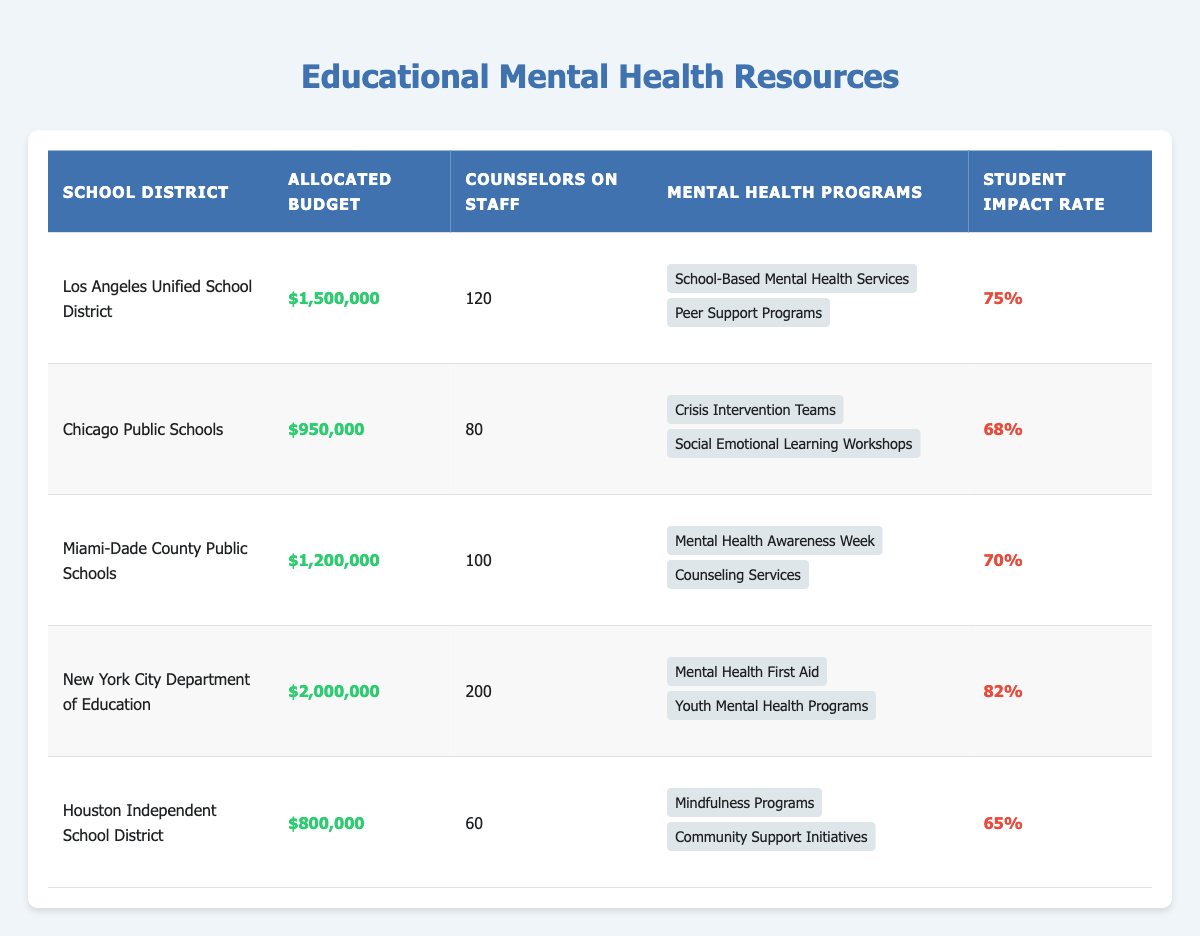What is the allocated budget for the New York City Department of Education? The table indicates the allocated budget for the New York City Department of Education as $2,000,000. This value is found directly under the "Allocated Budget" column in the row corresponding to New York City.
Answer: $2,000,000 How many counselors are on staff at Chicago Public Schools? From the table, the number of counselors on staff at Chicago Public Schools is 80, which is listed in the row specific to that district.
Answer: 80 Which school district has the highest student impact rate? The student impact rates for each district are listed, with New York City having the highest rate at 82%. This requires comparing the impact rates provided in each row to determine the maximum.
Answer: New York City Department of Education What is the average allocated budget across all school districts? To calculate the average allocated budget, sum the allocated budgets: $1,500,000 + $950,000 + $1,200,000 + $2,000,000 + $800,000 = $6,450,000. Then divide by the number of districts, which is 5: $6,450,000 / 5 = $1,290,000.
Answer: $1,290,000 Does the Houston Independent School District have more counselors than the Miami-Dade County Public Schools? The table shows that Houston has 60 counselors, while Miami-Dade has 100 counselors. Since 60 is less than 100, the statement is false. The comparison is made directly from the values in the respective rows.
Answer: No What is the difference in student impact rate between the top and bottom districts? From the table, New York City has an impact rate of 82%, and Houston has an impact rate of 65%. The difference is calculated as 82% - 65% = 17%. This requires identifying the highest and lowest rates first.
Answer: 17% Which mental health program is unique to Los Angeles Unified School District? The table lists two programs for Los Angeles: "School-Based Mental Health Services" and "Peer Support Programs." There is no indication of other districts offering these specific programs, as the programs listed for each district differ. Therefore, both programs can be considered unique in the context of the data provided.
Answer: School-Based Mental Health Services, Peer Support Programs Is the total number of counselors across all districts greater than 400? The total number of counselors is calculated as follows: 120 (Los Angeles) + 80 (Chicago) + 100 (Miami-Dade) + 200 (New York City) + 60 (Houston) = 660. Since 660 is greater than 400, the statement is true.
Answer: Yes What is the lowest allocated budget among the five school districts? The table shows the allocated budgets for all districts: Los Angeles - $1,500,000, Chicago - $950,000, Miami-Dade - $1,200,000, New York City - $2,000,000, and Houston - $800,000. The lowest value is $800,000, found in the row for Houston, thus identifying the minimum budget among the districts.
Answer: $800,000 